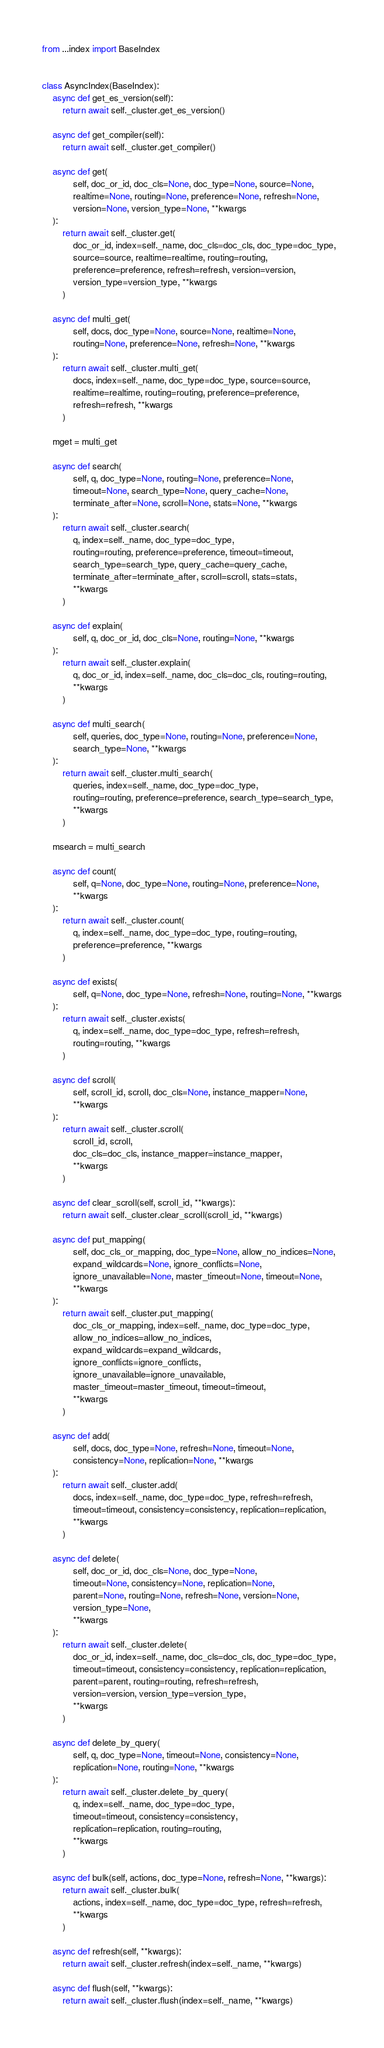Convert code to text. <code><loc_0><loc_0><loc_500><loc_500><_Python_>from ...index import BaseIndex


class AsyncIndex(BaseIndex):
    async def get_es_version(self):
        return await self._cluster.get_es_version()

    async def get_compiler(self):
        return await self._cluster.get_compiler()

    async def get(
            self, doc_or_id, doc_cls=None, doc_type=None, source=None,
            realtime=None, routing=None, preference=None, refresh=None,
            version=None, version_type=None, **kwargs
    ):
        return await self._cluster.get(
            doc_or_id, index=self._name, doc_cls=doc_cls, doc_type=doc_type,
            source=source, realtime=realtime, routing=routing,
            preference=preference, refresh=refresh, version=version,
            version_type=version_type, **kwargs
        )

    async def multi_get(
            self, docs, doc_type=None, source=None, realtime=None,
            routing=None, preference=None, refresh=None, **kwargs
    ):
        return await self._cluster.multi_get(
            docs, index=self._name, doc_type=doc_type, source=source,
            realtime=realtime, routing=routing, preference=preference,
            refresh=refresh, **kwargs
        )

    mget = multi_get

    async def search(
            self, q, doc_type=None, routing=None, preference=None,
            timeout=None, search_type=None, query_cache=None,
            terminate_after=None, scroll=None, stats=None, **kwargs
    ):
        return await self._cluster.search(
            q, index=self._name, doc_type=doc_type,
            routing=routing, preference=preference, timeout=timeout,
            search_type=search_type, query_cache=query_cache,
            terminate_after=terminate_after, scroll=scroll, stats=stats,
            **kwargs
        )

    async def explain(
            self, q, doc_or_id, doc_cls=None, routing=None, **kwargs
    ):
        return await self._cluster.explain(
            q, doc_or_id, index=self._name, doc_cls=doc_cls, routing=routing,
            **kwargs
        )

    async def multi_search(
            self, queries, doc_type=None, routing=None, preference=None,
            search_type=None, **kwargs
    ):
        return await self._cluster.multi_search(
            queries, index=self._name, doc_type=doc_type,
            routing=routing, preference=preference, search_type=search_type,
            **kwargs
        )

    msearch = multi_search

    async def count(
            self, q=None, doc_type=None, routing=None, preference=None,
            **kwargs
    ):
        return await self._cluster.count(
            q, index=self._name, doc_type=doc_type, routing=routing,
            preference=preference, **kwargs
        )

    async def exists(
            self, q=None, doc_type=None, refresh=None, routing=None, **kwargs
    ):
        return await self._cluster.exists(
            q, index=self._name, doc_type=doc_type, refresh=refresh,
            routing=routing, **kwargs
        )

    async def scroll(
            self, scroll_id, scroll, doc_cls=None, instance_mapper=None,
            **kwargs
    ):
        return await self._cluster.scroll(
            scroll_id, scroll,
            doc_cls=doc_cls, instance_mapper=instance_mapper,
            **kwargs
        )

    async def clear_scroll(self, scroll_id, **kwargs):
        return await self._cluster.clear_scroll(scroll_id, **kwargs)

    async def put_mapping(
            self, doc_cls_or_mapping, doc_type=None, allow_no_indices=None,
            expand_wildcards=None, ignore_conflicts=None,
            ignore_unavailable=None, master_timeout=None, timeout=None,
            **kwargs
    ):
        return await self._cluster.put_mapping(
            doc_cls_or_mapping, index=self._name, doc_type=doc_type,
            allow_no_indices=allow_no_indices,
            expand_wildcards=expand_wildcards,
            ignore_conflicts=ignore_conflicts,
            ignore_unavailable=ignore_unavailable,
            master_timeout=master_timeout, timeout=timeout,
            **kwargs
        )

    async def add(
            self, docs, doc_type=None, refresh=None, timeout=None,
            consistency=None, replication=None, **kwargs
    ):
        return await self._cluster.add(
            docs, index=self._name, doc_type=doc_type, refresh=refresh,
            timeout=timeout, consistency=consistency, replication=replication,
            **kwargs
        )

    async def delete(
            self, doc_or_id, doc_cls=None, doc_type=None,
            timeout=None, consistency=None, replication=None,
            parent=None, routing=None, refresh=None, version=None,
            version_type=None,
            **kwargs
    ):
        return await self._cluster.delete(
            doc_or_id, index=self._name, doc_cls=doc_cls, doc_type=doc_type,
            timeout=timeout, consistency=consistency, replication=replication,
            parent=parent, routing=routing, refresh=refresh,
            version=version, version_type=version_type,
            **kwargs
        )

    async def delete_by_query(
            self, q, doc_type=None, timeout=None, consistency=None,
            replication=None, routing=None, **kwargs
    ):
        return await self._cluster.delete_by_query(
            q, index=self._name, doc_type=doc_type,
            timeout=timeout, consistency=consistency,
            replication=replication, routing=routing,
            **kwargs
        )

    async def bulk(self, actions, doc_type=None, refresh=None, **kwargs):
        return await self._cluster.bulk(
            actions, index=self._name, doc_type=doc_type, refresh=refresh,
            **kwargs
        )

    async def refresh(self, **kwargs):
        return await self._cluster.refresh(index=self._name, **kwargs)

    async def flush(self, **kwargs):
        return await self._cluster.flush(index=self._name, **kwargs)
</code> 